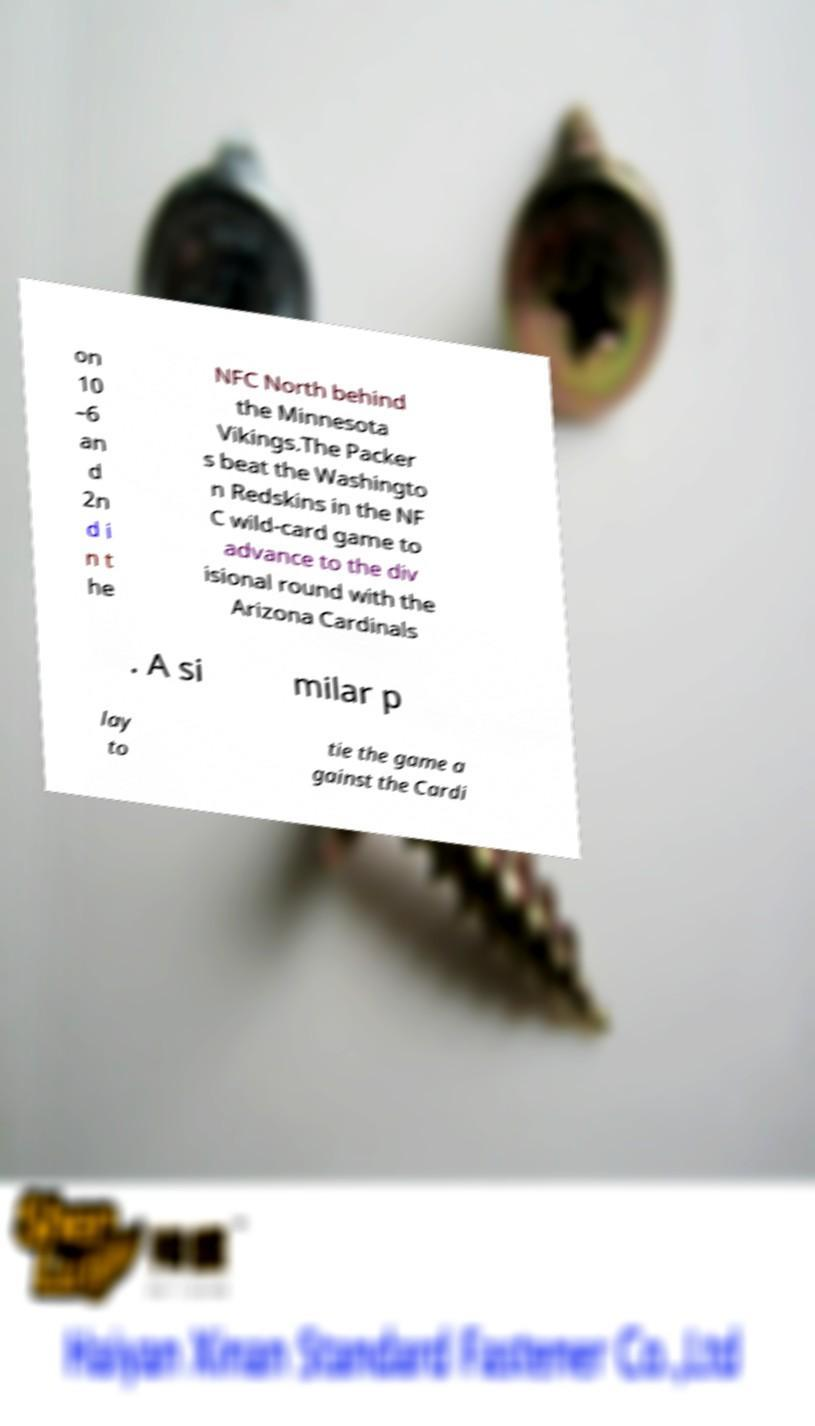For documentation purposes, I need the text within this image transcribed. Could you provide that? on 10 –6 an d 2n d i n t he NFC North behind the Minnesota Vikings.The Packer s beat the Washingto n Redskins in the NF C wild-card game to advance to the div isional round with the Arizona Cardinals . A si milar p lay to tie the game a gainst the Cardi 